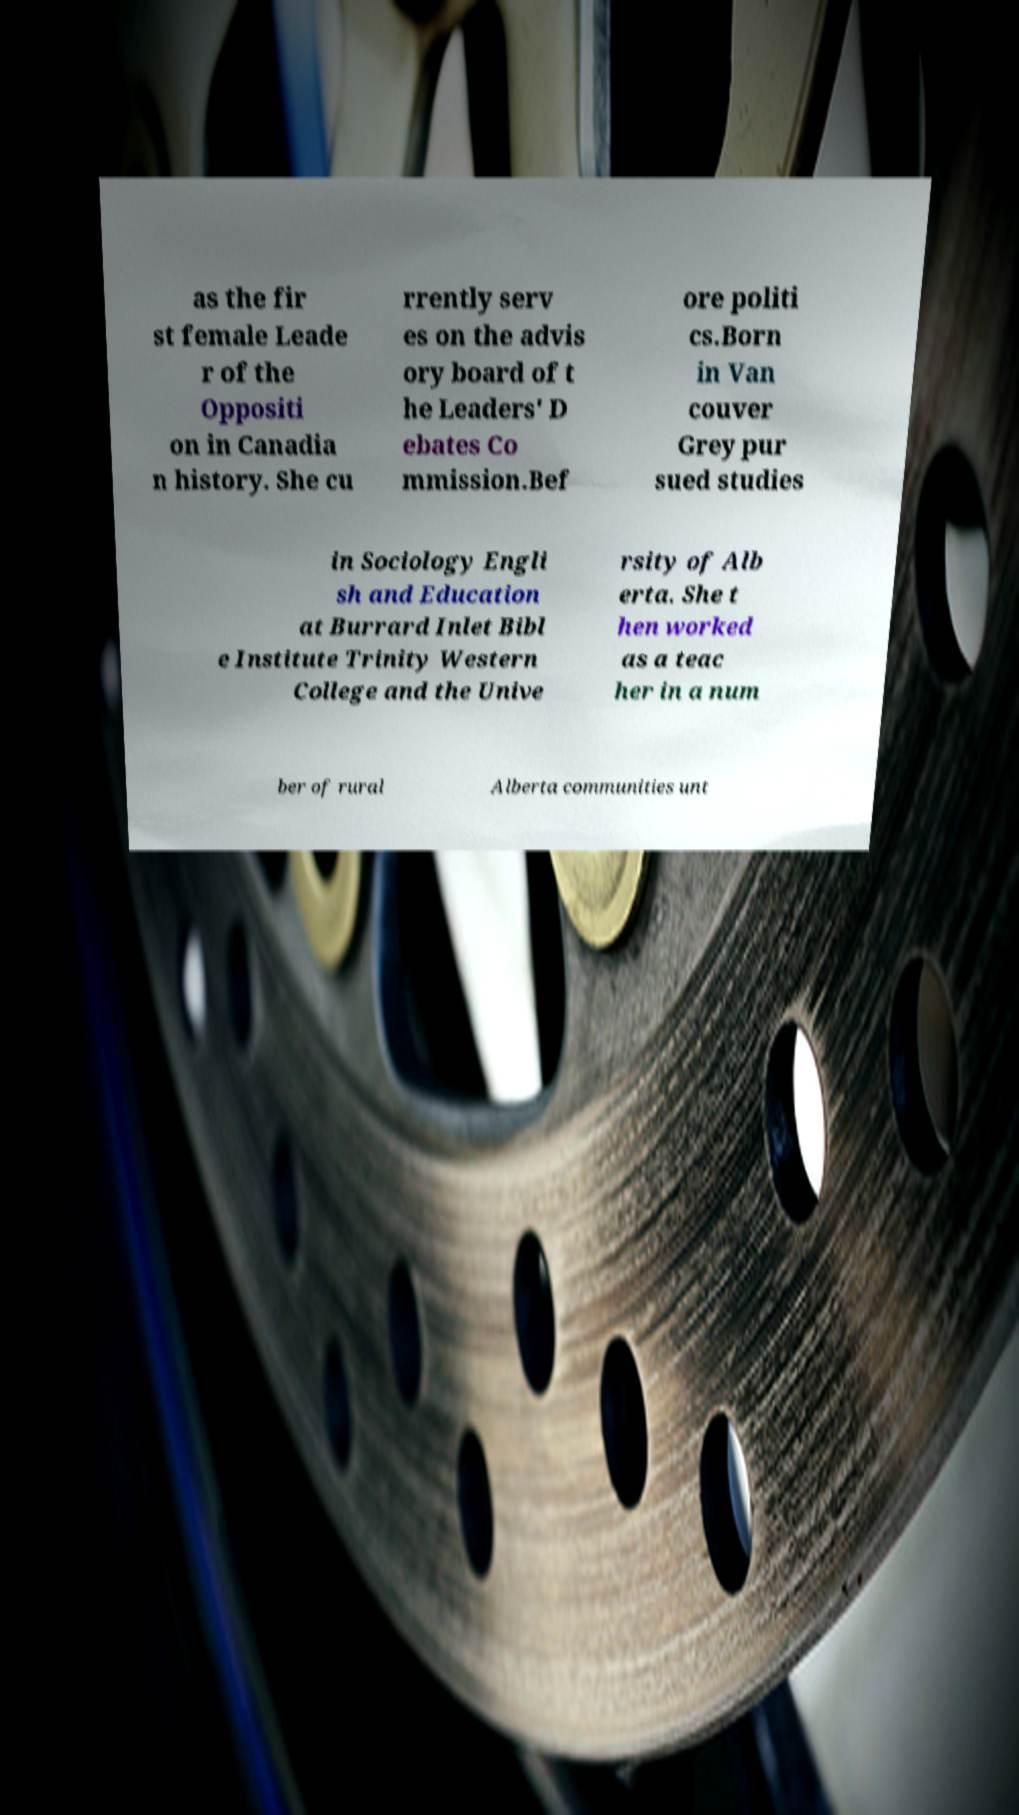Could you assist in decoding the text presented in this image and type it out clearly? as the fir st female Leade r of the Oppositi on in Canadia n history. She cu rrently serv es on the advis ory board of t he Leaders' D ebates Co mmission.Bef ore politi cs.Born in Van couver Grey pur sued studies in Sociology Engli sh and Education at Burrard Inlet Bibl e Institute Trinity Western College and the Unive rsity of Alb erta. She t hen worked as a teac her in a num ber of rural Alberta communities unt 